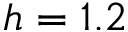<formula> <loc_0><loc_0><loc_500><loc_500>h = 1 . 2</formula> 